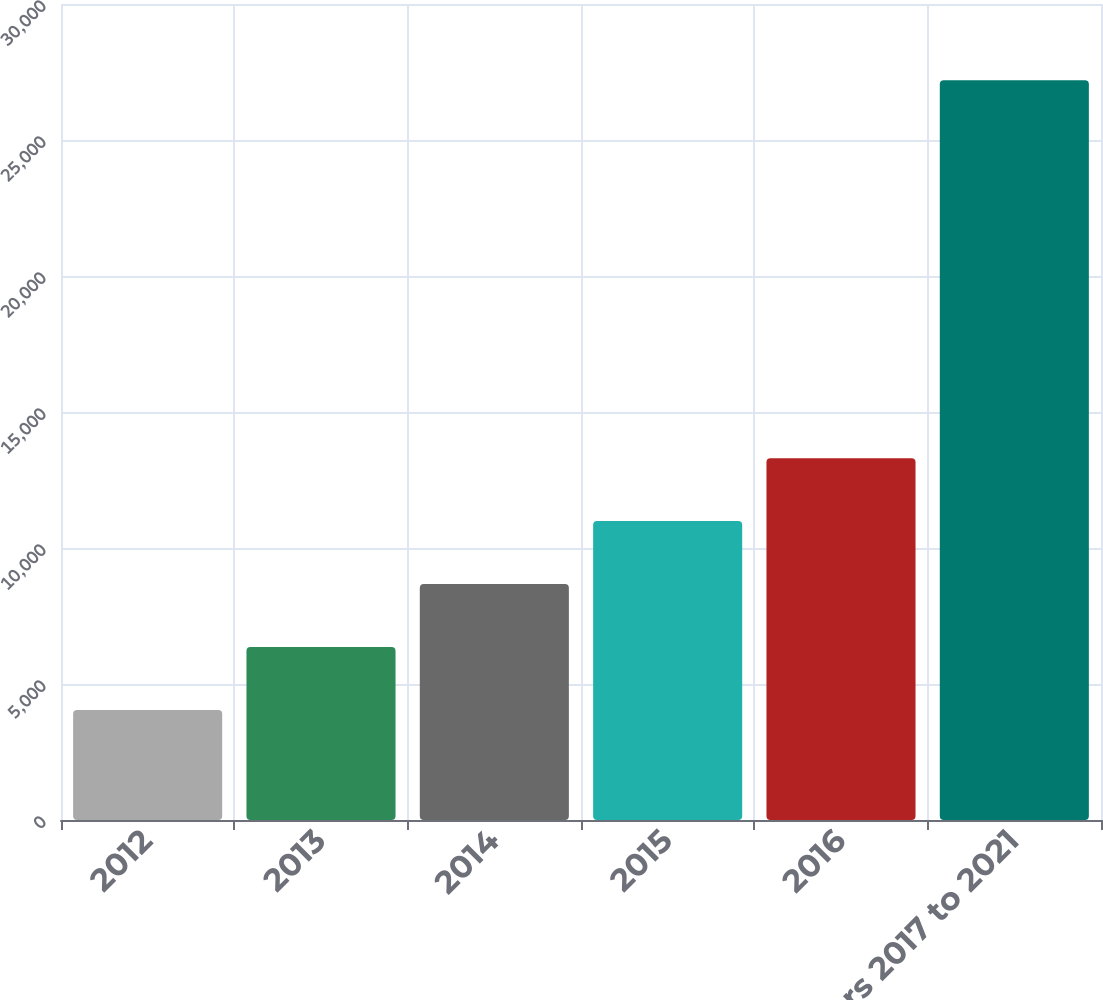<chart> <loc_0><loc_0><loc_500><loc_500><bar_chart><fcel>2012<fcel>2013<fcel>2014<fcel>2015<fcel>2016<fcel>Years 2017 to 2021<nl><fcel>4041<fcel>6356.8<fcel>8672.6<fcel>10988.4<fcel>13304.2<fcel>27199<nl></chart> 